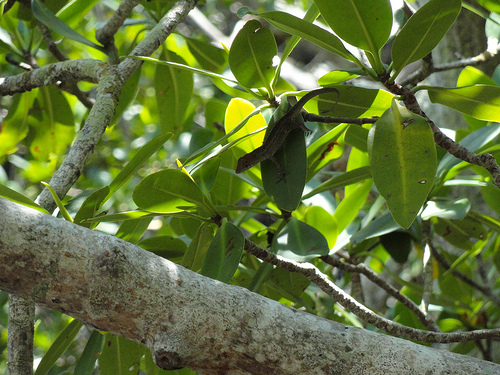<image>
Can you confirm if the branch is above the limb? Yes. The branch is positioned above the limb in the vertical space, higher up in the scene. 